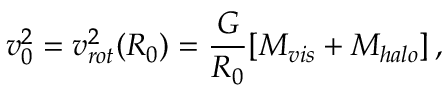Convert formula to latex. <formula><loc_0><loc_0><loc_500><loc_500>v _ { 0 } ^ { 2 } = v _ { r o t } ^ { 2 } ( R _ { 0 } ) = \frac { G } { R _ { 0 } } [ M _ { v i s } + M _ { h a l o } ] \, ,</formula> 